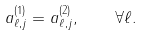<formula> <loc_0><loc_0><loc_500><loc_500>a _ { \ell , j } ^ { ( 1 ) } = a _ { \ell , j } ^ { ( 2 ) } , \quad \forall \ell .</formula> 